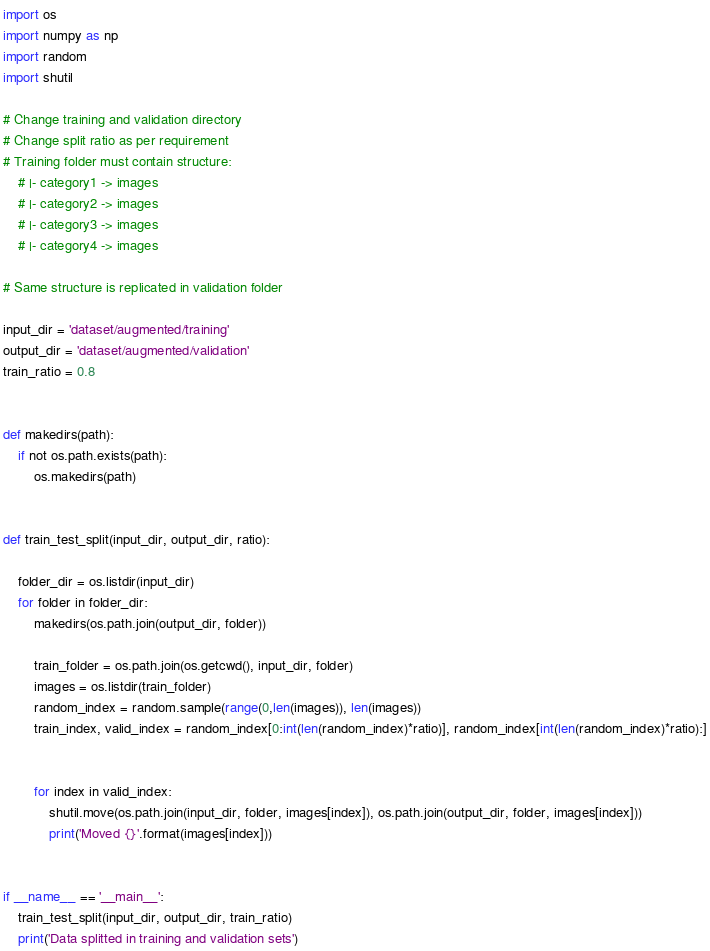<code> <loc_0><loc_0><loc_500><loc_500><_Python_>import os
import numpy as np
import random
import shutil

# Change training and validation directory
# Change split ratio as per requirement
# Training folder must contain structure:
	# |- category1 -> images
	# |- category2 -> images
	# |- category3 -> images
	# |- category4 -> images

# Same structure is replicated in validation folder

input_dir = 'dataset/augmented/training'
output_dir = 'dataset/augmented/validation'
train_ratio = 0.8


def makedirs(path):
	if not os.path.exists(path):
		os.makedirs(path)


def train_test_split(input_dir, output_dir, ratio):
	
	folder_dir = os.listdir(input_dir)
	for folder in folder_dir:
		makedirs(os.path.join(output_dir, folder))

		train_folder = os.path.join(os.getcwd(), input_dir, folder)
		images = os.listdir(train_folder)
		random_index = random.sample(range(0,len(images)), len(images))
		train_index, valid_index = random_index[0:int(len(random_index)*ratio)], random_index[int(len(random_index)*ratio):]
		

		for index in valid_index:
			shutil.move(os.path.join(input_dir, folder, images[index]), os.path.join(output_dir, folder, images[index]))
			print('Moved {}'.format(images[index]))


if __name__ == '__main__':
	train_test_split(input_dir, output_dir, train_ratio)
	print('Data splitted in training and validation sets')</code> 